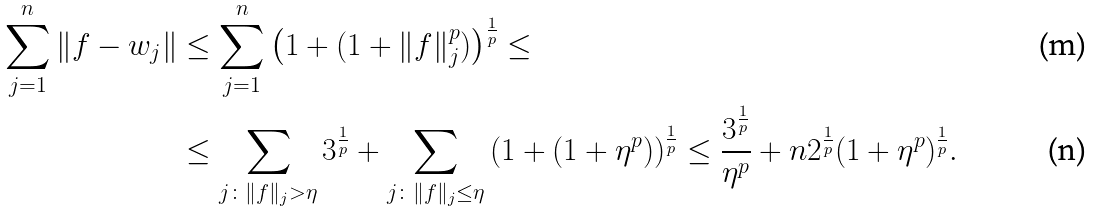Convert formula to latex. <formula><loc_0><loc_0><loc_500><loc_500>\sum _ { j = 1 } ^ { n } \| f - w _ { j } \| & \leq \sum _ { j = 1 } ^ { n } \left ( 1 + ( 1 + \| f \| ^ { p } _ { j } ) \right ) ^ { \frac { 1 } { p } } \leq \\ & \leq \sum _ { j \colon \| f \| _ { j } > \eta } 3 ^ { \frac { 1 } { p } } + \sum _ { j \colon \| f \| _ { j } \leq \eta } \left ( 1 + ( 1 + \eta ^ { p } ) \right ) ^ { \frac { 1 } { p } } \leq \frac { 3 ^ { \frac { 1 } { p } } } { \eta ^ { p } } + n 2 ^ { \frac { 1 } { p } } ( 1 + \eta ^ { p } ) ^ { \frac { 1 } { p } } .</formula> 